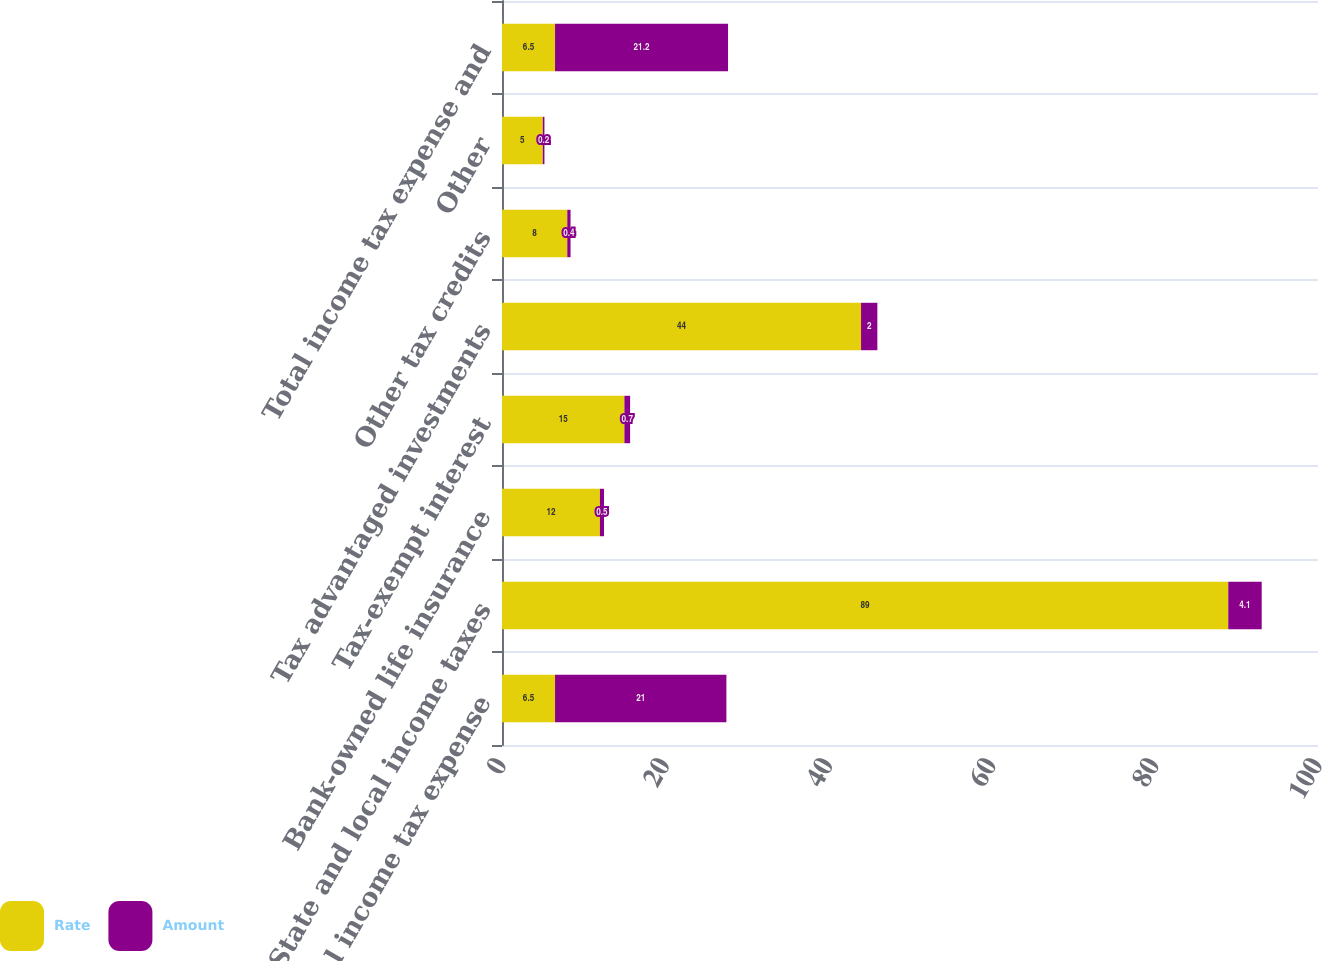<chart> <loc_0><loc_0><loc_500><loc_500><stacked_bar_chart><ecel><fcel>US Federal income tax expense<fcel>State and local income taxes<fcel>Bank-owned life insurance<fcel>Tax-exempt interest<fcel>Tax advantaged investments<fcel>Other tax credits<fcel>Other<fcel>Total income tax expense and<nl><fcel>Rate<fcel>6.5<fcel>89<fcel>12<fcel>15<fcel>44<fcel>8<fcel>5<fcel>6.5<nl><fcel>Amount<fcel>21<fcel>4.1<fcel>0.5<fcel>0.7<fcel>2<fcel>0.4<fcel>0.2<fcel>21.2<nl></chart> 